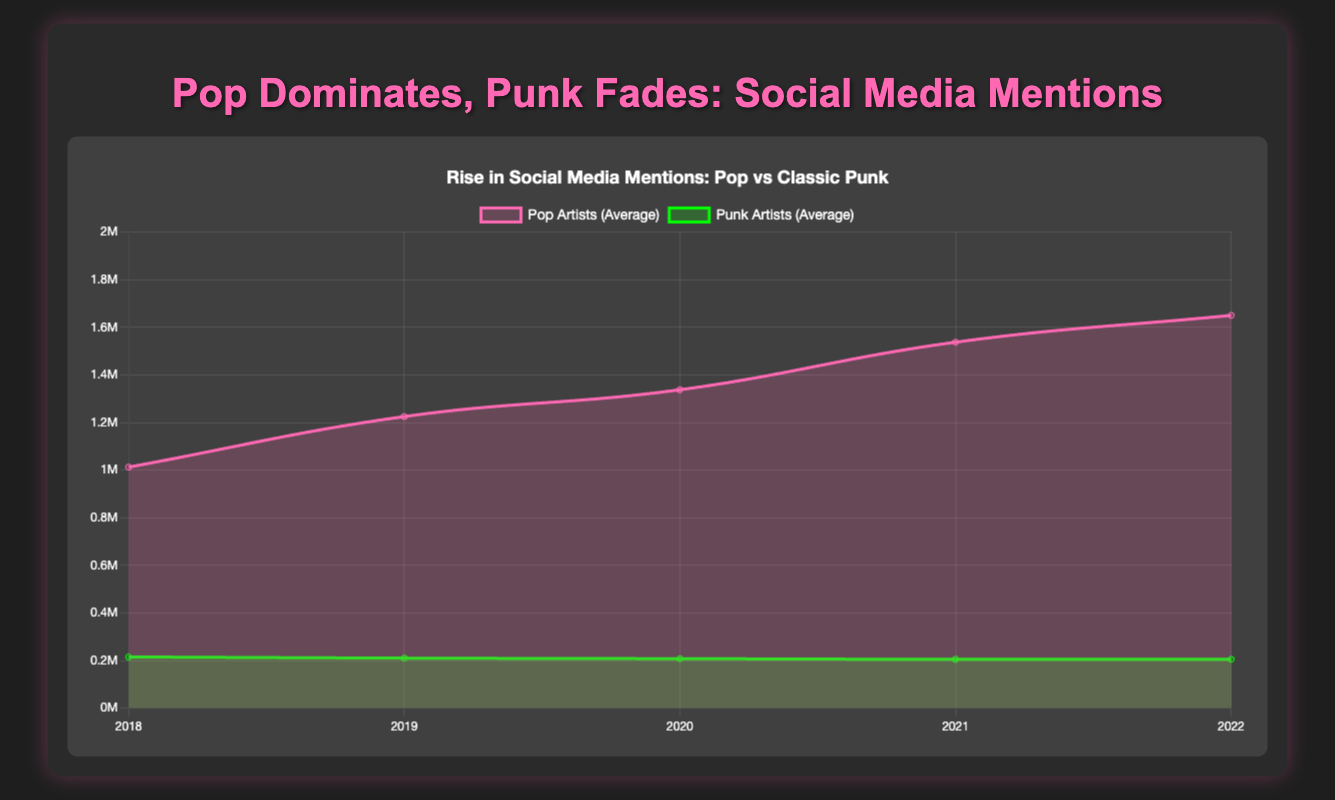What is the overall trend for social media mentions of pop artists over the last 5 years? To identify the overall trend, observe the line for pop artists (pink line). Starting from 2018 to 2022, the trend line for pop artists' mentions shows a steady increase over the years, going from around 1 million mentions on average in 2018 up to 1.65 million mentions on average by 2022.
Answer: Steady increase How do the social media mentions for pop artists in 2022 compare to those in 2018? In 2018, the average mentions for pop artists were around 1,012,500. In 2022, this increased to 1,650,000. Comparing these two values shows that the number of mentions for pop artists has increased significantly over these years.
Answer: Increase Between which years did pop artists see the largest increase in social media mentions? To determine this, observe the increments between consecutive years on the pop artists' trend line. The largest jump occurs between 2020 (1,337,500) and 2021 (1,537,500), with an increase of 200,000 mentions.
Answer: Between 2020 and 2021 What is the average number of mentions for punk artists over the entire 5 years? The average mentions per year for punk artists are: 215,000 for 2018, 210,000 for 2019, 207,500 for 2020, 205,000 for 2021, and 205,000 for 2022. Summing these and dividing by 5 gives (215,000 + 210,000 + 207,500 + 205,000 + 205,000) / 5 = 1,042,500 / 5 = 208,500.
Answer: 208,500 Which year had the maximum average social media mentions for classic punk artists? By looking at the green line representing punk artists over the years, the highest peak is at 2018 with 215,000 mentions.
Answer: 2018 How does the trend for punk artists compare to the trend for pop artists over the 5 years? The pink line for pop artists shows a steady upwards trend, whereas the green line for punk artists is nearly flat with a slight decline. This indicates that mentions for pop artists have been rising significantly, whereas punk artists have seen little change over time.
Answer: Pop rising, Punk stable/declining What is the difference between the average mentions of pop and punk artists in 2021? For pop artists in 2021, the average mentions are 1,537,500. For punk artists in the same year, the average mentions are 205,000. The difference is 1,537,500 - 205,000 = 1,332,500.
Answer: 1,332,500 What trend can you observe in the social media mentions of Ariana Grande from 2018 to 2020? By evaluating the data for Ariana Grande: mentions in 2018 are 900,000, in 2019 they are 1,000,000, and in 2020 they are 1,200,000. Hence, there's a consistent increase over these years.
Answer: Consistent increase Which year shows the lowest average mentions for classic punk artists? Observing the green line, the lowest average for punk artists is equally shared between 2021 and 2022, both at 205,000 mentions.
Answer: 2021 and 2022 